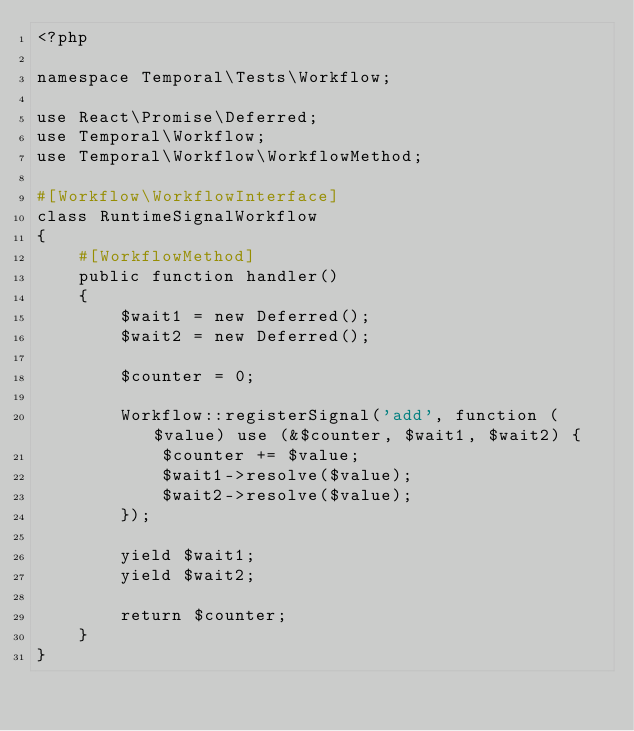<code> <loc_0><loc_0><loc_500><loc_500><_PHP_><?php

namespace Temporal\Tests\Workflow;

use React\Promise\Deferred;
use Temporal\Workflow;
use Temporal\Workflow\WorkflowMethod;

#[Workflow\WorkflowInterface]
class RuntimeSignalWorkflow
{
    #[WorkflowMethod]
    public function handler()
    {
        $wait1 = new Deferred();
        $wait2 = new Deferred();

        $counter = 0;

        Workflow::registerSignal('add', function ($value) use (&$counter, $wait1, $wait2) {
            $counter += $value;
            $wait1->resolve($value);
            $wait2->resolve($value);
        });

        yield $wait1;
        yield $wait2;

        return $counter;
    }
}
</code> 